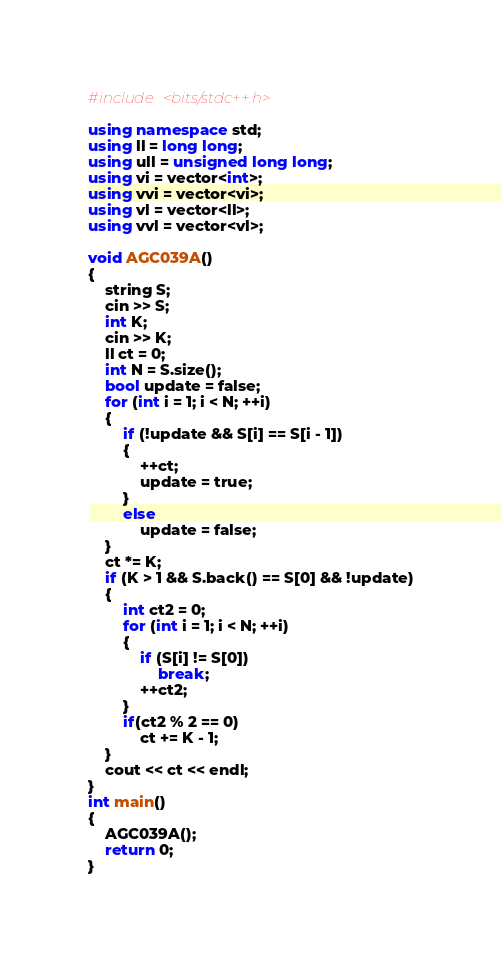<code> <loc_0><loc_0><loc_500><loc_500><_C++_>#include <bits/stdc++.h>

using namespace std;
using ll = long long;
using ull = unsigned long long;
using vi = vector<int>;
using vvi = vector<vi>;
using vl = vector<ll>;
using vvl = vector<vl>;

void AGC039A()
{
	string S;
	cin >> S;
	int K;
	cin >> K;
	ll ct = 0;
	int N = S.size();
	bool update = false;
	for (int i = 1; i < N; ++i)
	{
		if (!update && S[i] == S[i - 1])
		{
			++ct;
			update = true;
		}
		else
			update = false;
	}
	ct *= K;
	if (K > 1 && S.back() == S[0] && !update)
	{
		int ct2 = 0;
		for (int i = 1; i < N; ++i)
		{
			if (S[i] != S[0])
				break;
			++ct2;
		}
		if(ct2 % 2 == 0)
			ct += K - 1;
	}
	cout << ct << endl;
}
int main()
{
	AGC039A();
	return 0;
}</code> 